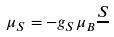Convert formula to latex. <formula><loc_0><loc_0><loc_500><loc_500>\mu _ { S } = - g _ { S } \mu _ { B } \frac { S } { }</formula> 